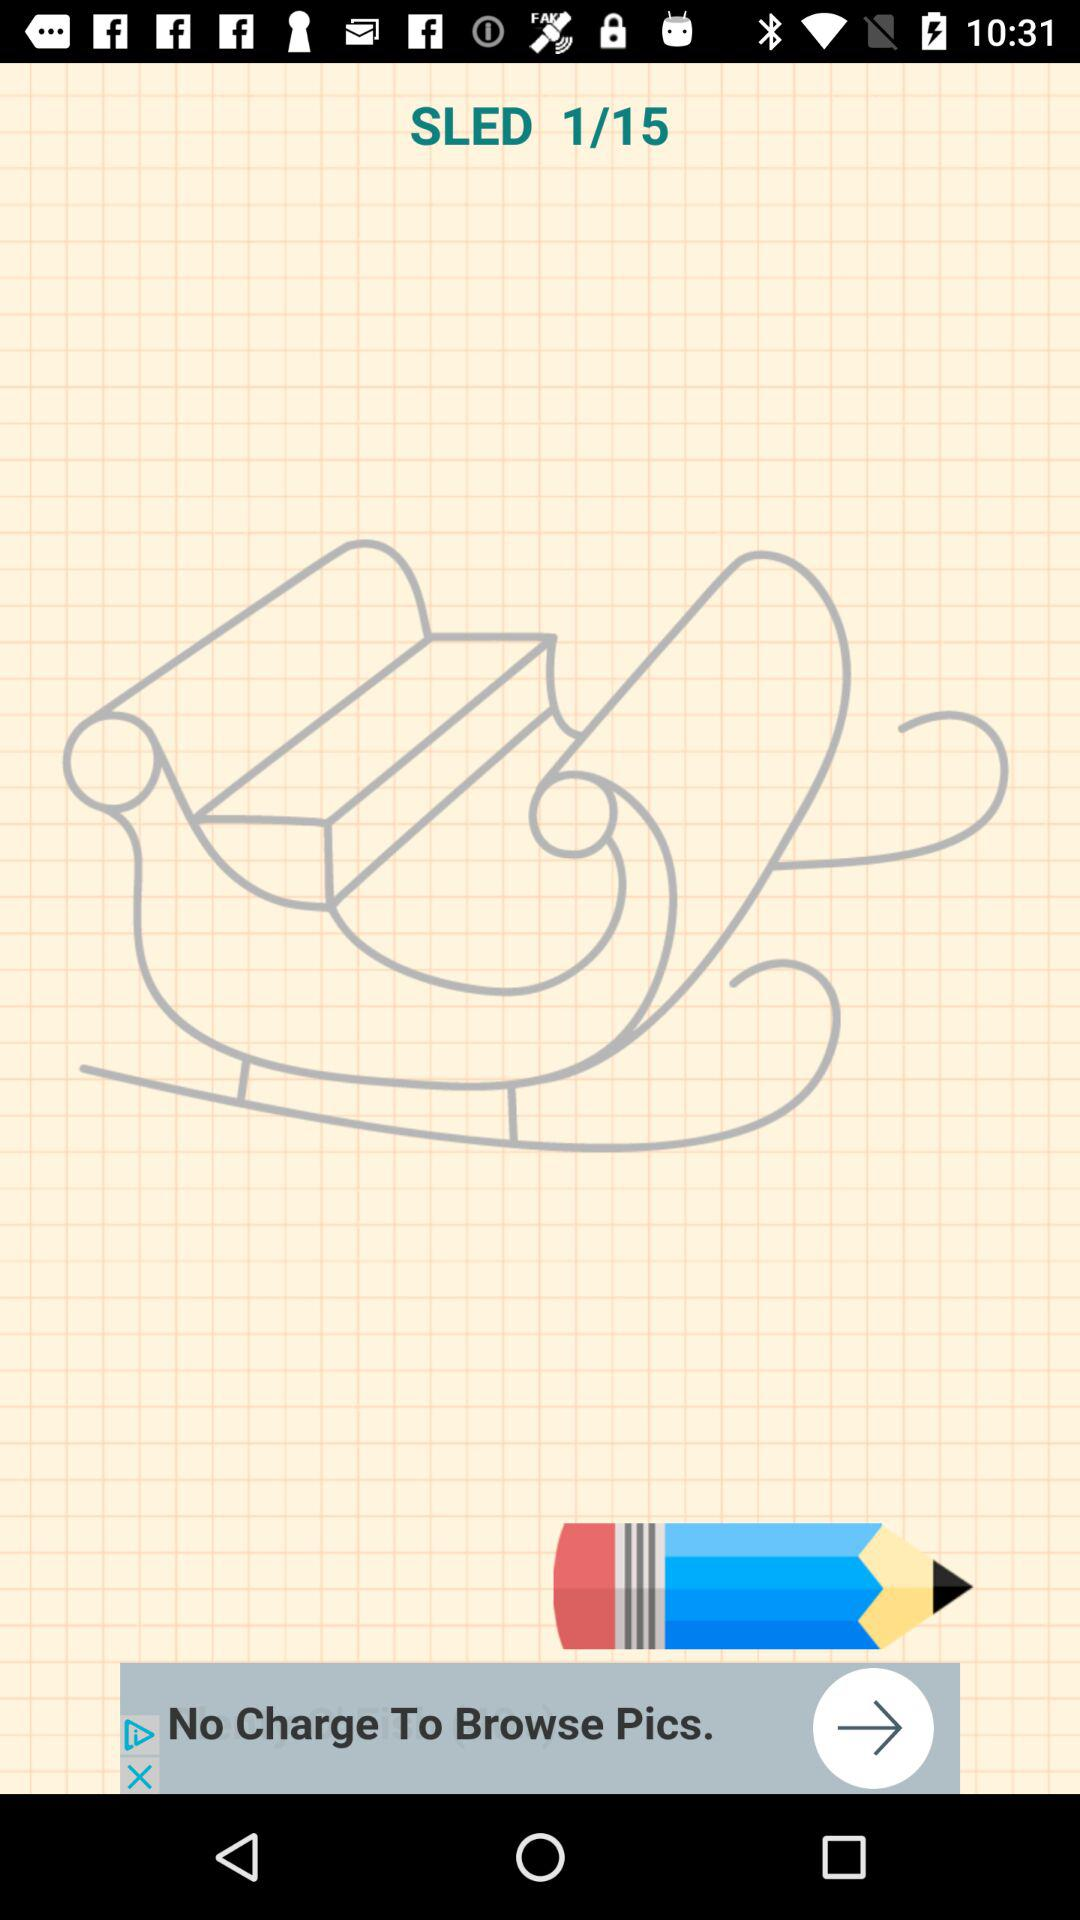How many images in total are there? There are 15 images in total. 